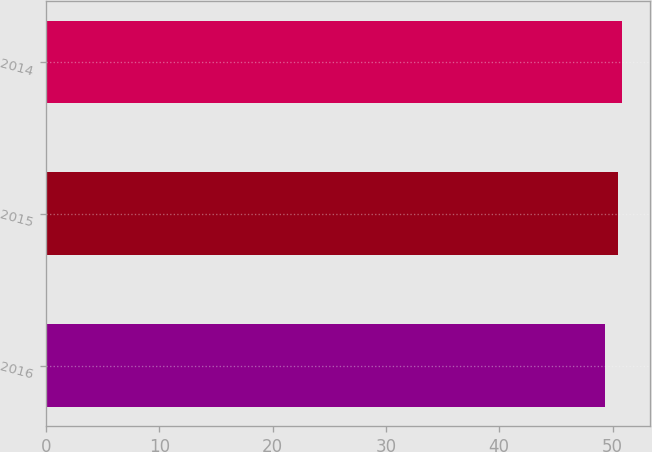Convert chart. <chart><loc_0><loc_0><loc_500><loc_500><bar_chart><fcel>2016<fcel>2015<fcel>2014<nl><fcel>49.3<fcel>50.5<fcel>50.8<nl></chart> 